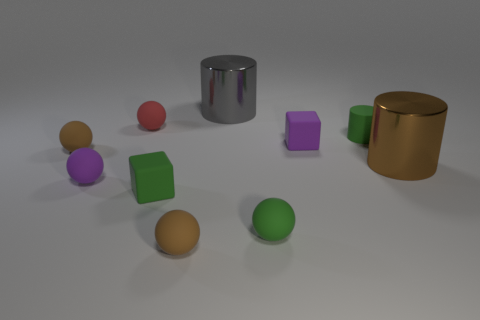Subtract 1 spheres. How many spheres are left? 4 Subtract all green matte balls. How many balls are left? 4 Subtract all red spheres. How many spheres are left? 4 Subtract all cyan balls. Subtract all gray blocks. How many balls are left? 5 Subtract all cylinders. How many objects are left? 7 Add 7 brown metal cylinders. How many brown metal cylinders exist? 8 Subtract 0 blue spheres. How many objects are left? 10 Subtract all big cylinders. Subtract all red balls. How many objects are left? 7 Add 5 small rubber cylinders. How many small rubber cylinders are left? 6 